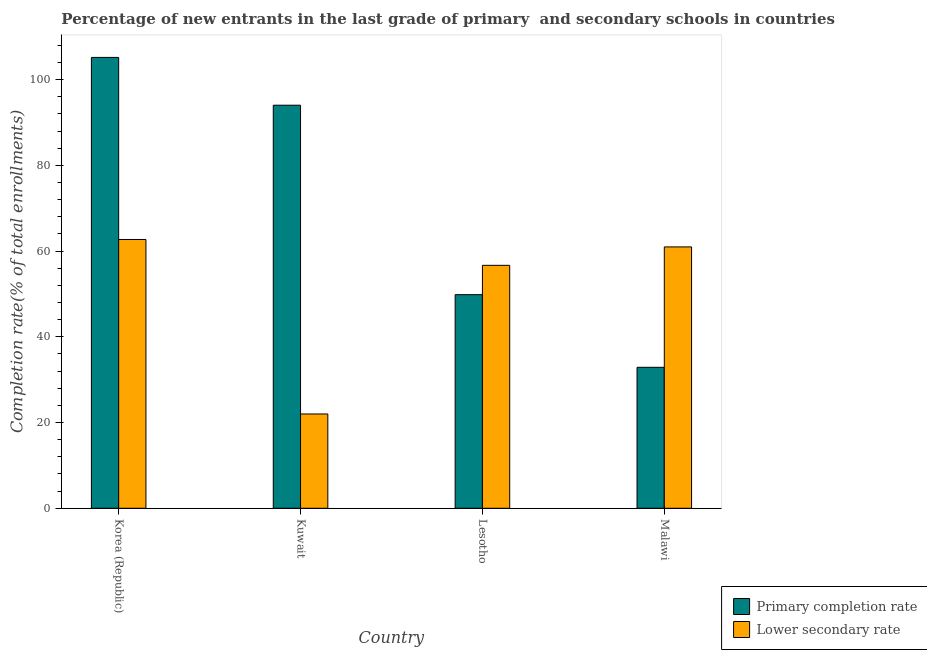How many different coloured bars are there?
Your response must be concise. 2. Are the number of bars per tick equal to the number of legend labels?
Make the answer very short. Yes. What is the label of the 4th group of bars from the left?
Ensure brevity in your answer.  Malawi. What is the completion rate in primary schools in Kuwait?
Keep it short and to the point. 94.03. Across all countries, what is the maximum completion rate in primary schools?
Provide a short and direct response. 105.17. Across all countries, what is the minimum completion rate in secondary schools?
Keep it short and to the point. 22. In which country was the completion rate in secondary schools minimum?
Keep it short and to the point. Kuwait. What is the total completion rate in secondary schools in the graph?
Provide a short and direct response. 202.34. What is the difference between the completion rate in primary schools in Kuwait and that in Lesotho?
Your answer should be compact. 44.2. What is the difference between the completion rate in primary schools in Malawi and the completion rate in secondary schools in Kuwait?
Your answer should be compact. 10.89. What is the average completion rate in primary schools per country?
Give a very brief answer. 70.48. What is the difference between the completion rate in secondary schools and completion rate in primary schools in Lesotho?
Keep it short and to the point. 6.84. In how many countries, is the completion rate in secondary schools greater than 12 %?
Provide a short and direct response. 4. What is the ratio of the completion rate in secondary schools in Korea (Republic) to that in Malawi?
Give a very brief answer. 1.03. Is the difference between the completion rate in primary schools in Lesotho and Malawi greater than the difference between the completion rate in secondary schools in Lesotho and Malawi?
Offer a very short reply. Yes. What is the difference between the highest and the second highest completion rate in primary schools?
Provide a succinct answer. 11.15. What is the difference between the highest and the lowest completion rate in secondary schools?
Your response must be concise. 40.71. Is the sum of the completion rate in primary schools in Kuwait and Malawi greater than the maximum completion rate in secondary schools across all countries?
Keep it short and to the point. Yes. What does the 2nd bar from the left in Malawi represents?
Your response must be concise. Lower secondary rate. What does the 1st bar from the right in Kuwait represents?
Keep it short and to the point. Lower secondary rate. How many countries are there in the graph?
Provide a succinct answer. 4. Does the graph contain any zero values?
Provide a succinct answer. No. How are the legend labels stacked?
Ensure brevity in your answer.  Vertical. What is the title of the graph?
Offer a very short reply. Percentage of new entrants in the last grade of primary  and secondary schools in countries. What is the label or title of the Y-axis?
Offer a terse response. Completion rate(% of total enrollments). What is the Completion rate(% of total enrollments) in Primary completion rate in Korea (Republic)?
Your response must be concise. 105.17. What is the Completion rate(% of total enrollments) in Lower secondary rate in Korea (Republic)?
Give a very brief answer. 62.7. What is the Completion rate(% of total enrollments) in Primary completion rate in Kuwait?
Provide a short and direct response. 94.03. What is the Completion rate(% of total enrollments) of Lower secondary rate in Kuwait?
Keep it short and to the point. 22. What is the Completion rate(% of total enrollments) in Primary completion rate in Lesotho?
Offer a terse response. 49.83. What is the Completion rate(% of total enrollments) of Lower secondary rate in Lesotho?
Provide a short and direct response. 56.67. What is the Completion rate(% of total enrollments) of Primary completion rate in Malawi?
Offer a terse response. 32.88. What is the Completion rate(% of total enrollments) of Lower secondary rate in Malawi?
Make the answer very short. 60.97. Across all countries, what is the maximum Completion rate(% of total enrollments) in Primary completion rate?
Ensure brevity in your answer.  105.17. Across all countries, what is the maximum Completion rate(% of total enrollments) in Lower secondary rate?
Offer a very short reply. 62.7. Across all countries, what is the minimum Completion rate(% of total enrollments) in Primary completion rate?
Your answer should be very brief. 32.88. Across all countries, what is the minimum Completion rate(% of total enrollments) of Lower secondary rate?
Offer a terse response. 22. What is the total Completion rate(% of total enrollments) in Primary completion rate in the graph?
Your answer should be compact. 281.92. What is the total Completion rate(% of total enrollments) of Lower secondary rate in the graph?
Your response must be concise. 202.34. What is the difference between the Completion rate(% of total enrollments) in Primary completion rate in Korea (Republic) and that in Kuwait?
Your response must be concise. 11.15. What is the difference between the Completion rate(% of total enrollments) in Lower secondary rate in Korea (Republic) and that in Kuwait?
Give a very brief answer. 40.71. What is the difference between the Completion rate(% of total enrollments) of Primary completion rate in Korea (Republic) and that in Lesotho?
Offer a very short reply. 55.34. What is the difference between the Completion rate(% of total enrollments) in Lower secondary rate in Korea (Republic) and that in Lesotho?
Offer a terse response. 6.03. What is the difference between the Completion rate(% of total enrollments) in Primary completion rate in Korea (Republic) and that in Malawi?
Keep it short and to the point. 72.29. What is the difference between the Completion rate(% of total enrollments) in Lower secondary rate in Korea (Republic) and that in Malawi?
Ensure brevity in your answer.  1.73. What is the difference between the Completion rate(% of total enrollments) of Primary completion rate in Kuwait and that in Lesotho?
Offer a terse response. 44.2. What is the difference between the Completion rate(% of total enrollments) in Lower secondary rate in Kuwait and that in Lesotho?
Make the answer very short. -34.68. What is the difference between the Completion rate(% of total enrollments) of Primary completion rate in Kuwait and that in Malawi?
Make the answer very short. 61.14. What is the difference between the Completion rate(% of total enrollments) in Lower secondary rate in Kuwait and that in Malawi?
Offer a very short reply. -38.97. What is the difference between the Completion rate(% of total enrollments) of Primary completion rate in Lesotho and that in Malawi?
Offer a terse response. 16.95. What is the difference between the Completion rate(% of total enrollments) of Lower secondary rate in Lesotho and that in Malawi?
Ensure brevity in your answer.  -4.3. What is the difference between the Completion rate(% of total enrollments) of Primary completion rate in Korea (Republic) and the Completion rate(% of total enrollments) of Lower secondary rate in Kuwait?
Offer a very short reply. 83.18. What is the difference between the Completion rate(% of total enrollments) in Primary completion rate in Korea (Republic) and the Completion rate(% of total enrollments) in Lower secondary rate in Lesotho?
Give a very brief answer. 48.5. What is the difference between the Completion rate(% of total enrollments) in Primary completion rate in Korea (Republic) and the Completion rate(% of total enrollments) in Lower secondary rate in Malawi?
Keep it short and to the point. 44.21. What is the difference between the Completion rate(% of total enrollments) of Primary completion rate in Kuwait and the Completion rate(% of total enrollments) of Lower secondary rate in Lesotho?
Offer a terse response. 37.35. What is the difference between the Completion rate(% of total enrollments) in Primary completion rate in Kuwait and the Completion rate(% of total enrollments) in Lower secondary rate in Malawi?
Your answer should be compact. 33.06. What is the difference between the Completion rate(% of total enrollments) in Primary completion rate in Lesotho and the Completion rate(% of total enrollments) in Lower secondary rate in Malawi?
Keep it short and to the point. -11.14. What is the average Completion rate(% of total enrollments) in Primary completion rate per country?
Your response must be concise. 70.48. What is the average Completion rate(% of total enrollments) of Lower secondary rate per country?
Your answer should be very brief. 50.59. What is the difference between the Completion rate(% of total enrollments) in Primary completion rate and Completion rate(% of total enrollments) in Lower secondary rate in Korea (Republic)?
Offer a very short reply. 42.47. What is the difference between the Completion rate(% of total enrollments) of Primary completion rate and Completion rate(% of total enrollments) of Lower secondary rate in Kuwait?
Make the answer very short. 72.03. What is the difference between the Completion rate(% of total enrollments) of Primary completion rate and Completion rate(% of total enrollments) of Lower secondary rate in Lesotho?
Keep it short and to the point. -6.84. What is the difference between the Completion rate(% of total enrollments) in Primary completion rate and Completion rate(% of total enrollments) in Lower secondary rate in Malawi?
Provide a succinct answer. -28.09. What is the ratio of the Completion rate(% of total enrollments) of Primary completion rate in Korea (Republic) to that in Kuwait?
Provide a succinct answer. 1.12. What is the ratio of the Completion rate(% of total enrollments) in Lower secondary rate in Korea (Republic) to that in Kuwait?
Offer a very short reply. 2.85. What is the ratio of the Completion rate(% of total enrollments) in Primary completion rate in Korea (Republic) to that in Lesotho?
Provide a succinct answer. 2.11. What is the ratio of the Completion rate(% of total enrollments) in Lower secondary rate in Korea (Republic) to that in Lesotho?
Keep it short and to the point. 1.11. What is the ratio of the Completion rate(% of total enrollments) in Primary completion rate in Korea (Republic) to that in Malawi?
Provide a succinct answer. 3.2. What is the ratio of the Completion rate(% of total enrollments) in Lower secondary rate in Korea (Republic) to that in Malawi?
Keep it short and to the point. 1.03. What is the ratio of the Completion rate(% of total enrollments) in Primary completion rate in Kuwait to that in Lesotho?
Offer a terse response. 1.89. What is the ratio of the Completion rate(% of total enrollments) of Lower secondary rate in Kuwait to that in Lesotho?
Ensure brevity in your answer.  0.39. What is the ratio of the Completion rate(% of total enrollments) of Primary completion rate in Kuwait to that in Malawi?
Provide a succinct answer. 2.86. What is the ratio of the Completion rate(% of total enrollments) in Lower secondary rate in Kuwait to that in Malawi?
Offer a terse response. 0.36. What is the ratio of the Completion rate(% of total enrollments) of Primary completion rate in Lesotho to that in Malawi?
Ensure brevity in your answer.  1.52. What is the ratio of the Completion rate(% of total enrollments) of Lower secondary rate in Lesotho to that in Malawi?
Ensure brevity in your answer.  0.93. What is the difference between the highest and the second highest Completion rate(% of total enrollments) of Primary completion rate?
Provide a succinct answer. 11.15. What is the difference between the highest and the second highest Completion rate(% of total enrollments) of Lower secondary rate?
Your answer should be compact. 1.73. What is the difference between the highest and the lowest Completion rate(% of total enrollments) in Primary completion rate?
Make the answer very short. 72.29. What is the difference between the highest and the lowest Completion rate(% of total enrollments) in Lower secondary rate?
Offer a terse response. 40.71. 